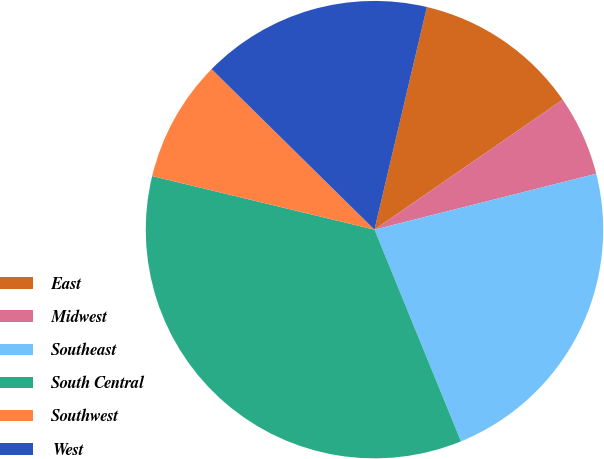Convert chart to OTSL. <chart><loc_0><loc_0><loc_500><loc_500><pie_chart><fcel>East<fcel>Midwest<fcel>Southeast<fcel>South Central<fcel>Southwest<fcel>West<nl><fcel>11.7%<fcel>5.69%<fcel>22.76%<fcel>34.94%<fcel>8.62%<fcel>16.3%<nl></chart> 